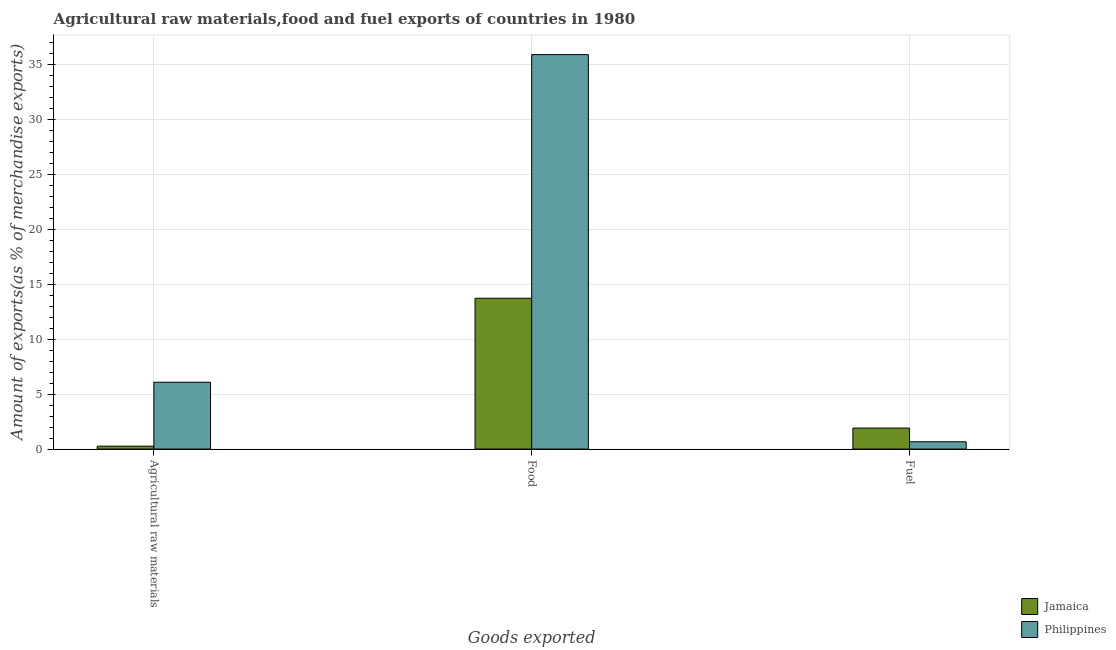How many different coloured bars are there?
Provide a succinct answer. 2. Are the number of bars on each tick of the X-axis equal?
Offer a very short reply. Yes. How many bars are there on the 3rd tick from the left?
Provide a short and direct response. 2. What is the label of the 1st group of bars from the left?
Your response must be concise. Agricultural raw materials. What is the percentage of food exports in Jamaica?
Your answer should be compact. 13.71. Across all countries, what is the maximum percentage of fuel exports?
Ensure brevity in your answer.  1.91. Across all countries, what is the minimum percentage of raw materials exports?
Provide a short and direct response. 0.26. In which country was the percentage of fuel exports maximum?
Offer a very short reply. Jamaica. What is the total percentage of food exports in the graph?
Your answer should be very brief. 49.57. What is the difference between the percentage of raw materials exports in Jamaica and that in Philippines?
Make the answer very short. -5.81. What is the difference between the percentage of raw materials exports in Jamaica and the percentage of fuel exports in Philippines?
Give a very brief answer. -0.4. What is the average percentage of fuel exports per country?
Provide a short and direct response. 1.29. What is the difference between the percentage of raw materials exports and percentage of food exports in Jamaica?
Provide a succinct answer. -13.45. What is the ratio of the percentage of fuel exports in Philippines to that in Jamaica?
Provide a short and direct response. 0.35. What is the difference between the highest and the second highest percentage of fuel exports?
Your answer should be very brief. 1.24. What is the difference between the highest and the lowest percentage of food exports?
Provide a short and direct response. 22.15. In how many countries, is the percentage of raw materials exports greater than the average percentage of raw materials exports taken over all countries?
Provide a succinct answer. 1. Is the sum of the percentage of food exports in Philippines and Jamaica greater than the maximum percentage of fuel exports across all countries?
Your answer should be compact. Yes. What does the 2nd bar from the right in Fuel represents?
Offer a very short reply. Jamaica. Is it the case that in every country, the sum of the percentage of raw materials exports and percentage of food exports is greater than the percentage of fuel exports?
Offer a terse response. Yes. How many countries are there in the graph?
Make the answer very short. 2. What is the difference between two consecutive major ticks on the Y-axis?
Provide a short and direct response. 5. Where does the legend appear in the graph?
Your response must be concise. Bottom right. How many legend labels are there?
Offer a terse response. 2. How are the legend labels stacked?
Make the answer very short. Vertical. What is the title of the graph?
Give a very brief answer. Agricultural raw materials,food and fuel exports of countries in 1980. What is the label or title of the X-axis?
Your answer should be compact. Goods exported. What is the label or title of the Y-axis?
Your answer should be compact. Amount of exports(as % of merchandise exports). What is the Amount of exports(as % of merchandise exports) in Jamaica in Agricultural raw materials?
Your answer should be compact. 0.26. What is the Amount of exports(as % of merchandise exports) in Philippines in Agricultural raw materials?
Make the answer very short. 6.08. What is the Amount of exports(as % of merchandise exports) in Jamaica in Food?
Provide a succinct answer. 13.71. What is the Amount of exports(as % of merchandise exports) in Philippines in Food?
Provide a succinct answer. 35.86. What is the Amount of exports(as % of merchandise exports) in Jamaica in Fuel?
Provide a succinct answer. 1.91. What is the Amount of exports(as % of merchandise exports) of Philippines in Fuel?
Your answer should be very brief. 0.66. Across all Goods exported, what is the maximum Amount of exports(as % of merchandise exports) of Jamaica?
Keep it short and to the point. 13.71. Across all Goods exported, what is the maximum Amount of exports(as % of merchandise exports) of Philippines?
Make the answer very short. 35.86. Across all Goods exported, what is the minimum Amount of exports(as % of merchandise exports) of Jamaica?
Ensure brevity in your answer.  0.26. Across all Goods exported, what is the minimum Amount of exports(as % of merchandise exports) of Philippines?
Your answer should be very brief. 0.66. What is the total Amount of exports(as % of merchandise exports) of Jamaica in the graph?
Offer a very short reply. 15.88. What is the total Amount of exports(as % of merchandise exports) in Philippines in the graph?
Offer a very short reply. 42.6. What is the difference between the Amount of exports(as % of merchandise exports) in Jamaica in Agricultural raw materials and that in Food?
Your response must be concise. -13.45. What is the difference between the Amount of exports(as % of merchandise exports) in Philippines in Agricultural raw materials and that in Food?
Ensure brevity in your answer.  -29.78. What is the difference between the Amount of exports(as % of merchandise exports) in Jamaica in Agricultural raw materials and that in Fuel?
Keep it short and to the point. -1.64. What is the difference between the Amount of exports(as % of merchandise exports) of Philippines in Agricultural raw materials and that in Fuel?
Give a very brief answer. 5.41. What is the difference between the Amount of exports(as % of merchandise exports) in Jamaica in Food and that in Fuel?
Give a very brief answer. 11.8. What is the difference between the Amount of exports(as % of merchandise exports) of Philippines in Food and that in Fuel?
Keep it short and to the point. 35.19. What is the difference between the Amount of exports(as % of merchandise exports) in Jamaica in Agricultural raw materials and the Amount of exports(as % of merchandise exports) in Philippines in Food?
Offer a terse response. -35.59. What is the difference between the Amount of exports(as % of merchandise exports) in Jamaica in Agricultural raw materials and the Amount of exports(as % of merchandise exports) in Philippines in Fuel?
Your answer should be very brief. -0.4. What is the difference between the Amount of exports(as % of merchandise exports) of Jamaica in Food and the Amount of exports(as % of merchandise exports) of Philippines in Fuel?
Ensure brevity in your answer.  13.05. What is the average Amount of exports(as % of merchandise exports) of Jamaica per Goods exported?
Ensure brevity in your answer.  5.29. What is the average Amount of exports(as % of merchandise exports) of Philippines per Goods exported?
Provide a succinct answer. 14.2. What is the difference between the Amount of exports(as % of merchandise exports) in Jamaica and Amount of exports(as % of merchandise exports) in Philippines in Agricultural raw materials?
Ensure brevity in your answer.  -5.81. What is the difference between the Amount of exports(as % of merchandise exports) of Jamaica and Amount of exports(as % of merchandise exports) of Philippines in Food?
Ensure brevity in your answer.  -22.15. What is the difference between the Amount of exports(as % of merchandise exports) of Jamaica and Amount of exports(as % of merchandise exports) of Philippines in Fuel?
Give a very brief answer. 1.24. What is the ratio of the Amount of exports(as % of merchandise exports) of Jamaica in Agricultural raw materials to that in Food?
Offer a terse response. 0.02. What is the ratio of the Amount of exports(as % of merchandise exports) of Philippines in Agricultural raw materials to that in Food?
Your answer should be compact. 0.17. What is the ratio of the Amount of exports(as % of merchandise exports) in Jamaica in Agricultural raw materials to that in Fuel?
Keep it short and to the point. 0.14. What is the ratio of the Amount of exports(as % of merchandise exports) of Philippines in Agricultural raw materials to that in Fuel?
Offer a very short reply. 9.15. What is the ratio of the Amount of exports(as % of merchandise exports) in Jamaica in Food to that in Fuel?
Provide a succinct answer. 7.19. What is the ratio of the Amount of exports(as % of merchandise exports) in Philippines in Food to that in Fuel?
Offer a terse response. 53.98. What is the difference between the highest and the second highest Amount of exports(as % of merchandise exports) of Jamaica?
Provide a short and direct response. 11.8. What is the difference between the highest and the second highest Amount of exports(as % of merchandise exports) in Philippines?
Offer a very short reply. 29.78. What is the difference between the highest and the lowest Amount of exports(as % of merchandise exports) of Jamaica?
Provide a succinct answer. 13.45. What is the difference between the highest and the lowest Amount of exports(as % of merchandise exports) in Philippines?
Keep it short and to the point. 35.19. 